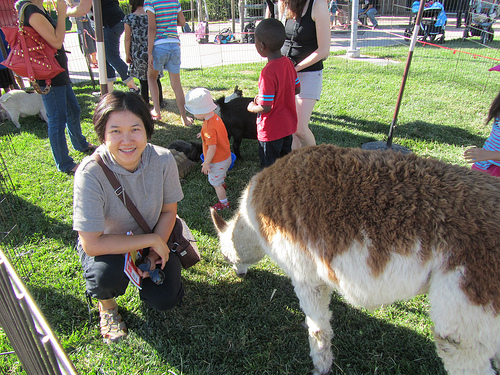Please provide a short description for this region: [0.49, 0.23, 0.6, 0.41]. The region shows the red shirt that the child is wearing, which stands out prominently. 